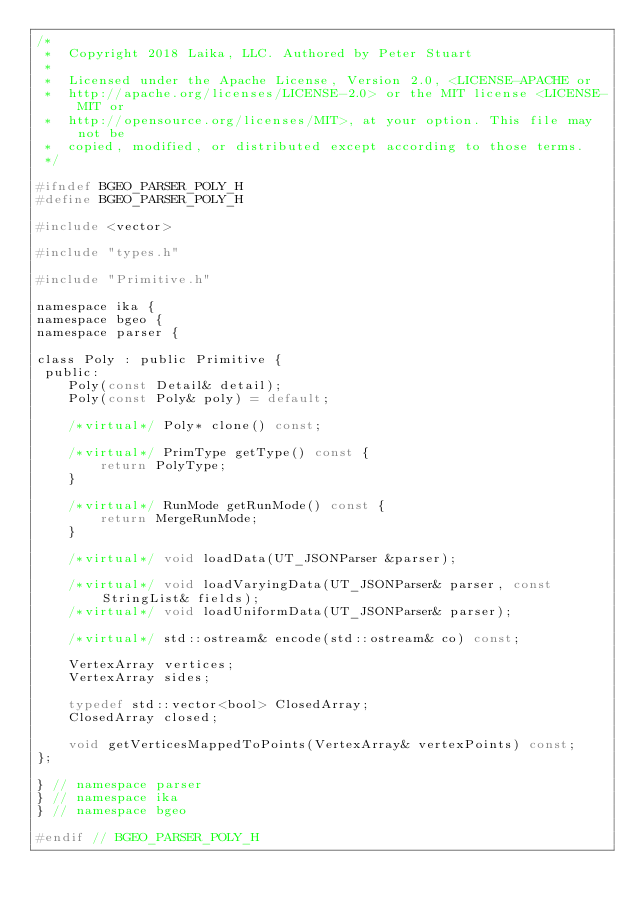Convert code to text. <code><loc_0><loc_0><loc_500><loc_500><_C_>/*
 *  Copyright 2018 Laika, LLC. Authored by Peter Stuart
 *
 *  Licensed under the Apache License, Version 2.0, <LICENSE-APACHE or
 *  http://apache.org/licenses/LICENSE-2.0> or the MIT license <LICENSE-MIT or
 *  http://opensource.org/licenses/MIT>, at your option. This file may not be
 *  copied, modified, or distributed except according to those terms.
 */

#ifndef BGEO_PARSER_POLY_H
#define BGEO_PARSER_POLY_H

#include <vector>

#include "types.h"

#include "Primitive.h"

namespace ika {
namespace bgeo {
namespace parser {

class Poly : public Primitive {
 public:
    Poly(const Detail& detail);
    Poly(const Poly& poly) = default;

    /*virtual*/ Poly* clone() const;

    /*virtual*/ PrimType getType() const {
        return PolyType;
    }

    /*virtual*/ RunMode getRunMode() const {
        return MergeRunMode;
    }

    /*virtual*/ void loadData(UT_JSONParser &parser);

    /*virtual*/ void loadVaryingData(UT_JSONParser& parser, const StringList& fields);
    /*virtual*/ void loadUniformData(UT_JSONParser& parser);

    /*virtual*/ std::ostream& encode(std::ostream& co) const;

    VertexArray vertices;
    VertexArray sides;

    typedef std::vector<bool> ClosedArray;
    ClosedArray closed;

    void getVerticesMappedToPoints(VertexArray& vertexPoints) const;
};

} // namespace parser
} // namespace ika
} // namespace bgeo

#endif // BGEO_PARSER_POLY_H
</code> 